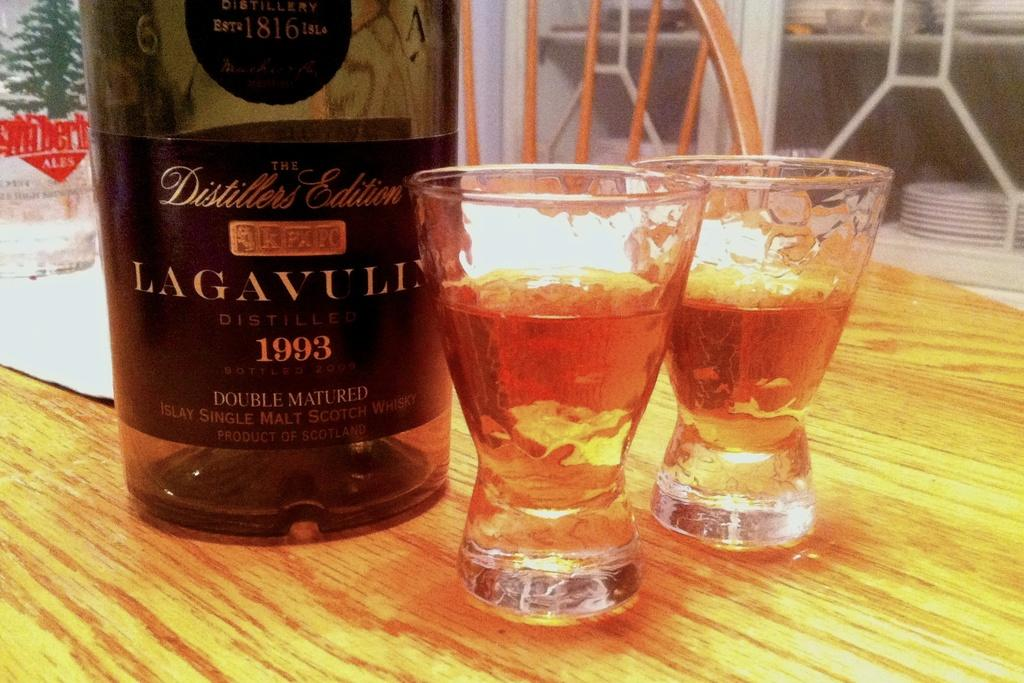<image>
Render a clear and concise summary of the photo. A bottle has the year 1993 on it with two glasses next to it. 